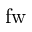Convert formula to latex. <formula><loc_0><loc_0><loc_500><loc_500>f w</formula> 